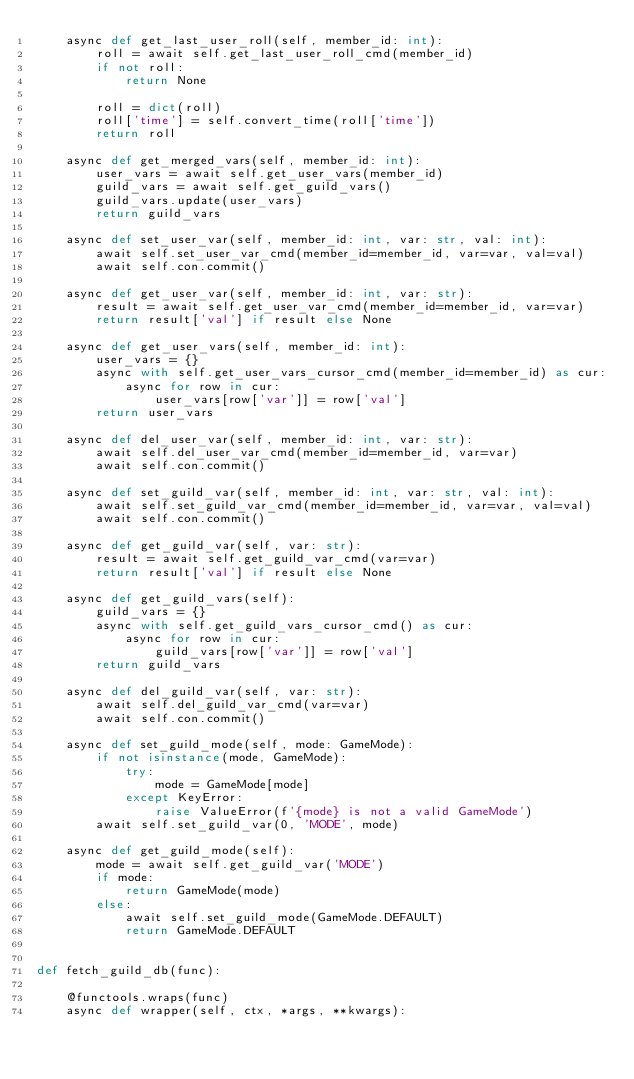<code> <loc_0><loc_0><loc_500><loc_500><_Python_>    async def get_last_user_roll(self, member_id: int):
        roll = await self.get_last_user_roll_cmd(member_id)
        if not roll:
            return None

        roll = dict(roll)
        roll['time'] = self.convert_time(roll['time'])
        return roll

    async def get_merged_vars(self, member_id: int):
        user_vars = await self.get_user_vars(member_id)
        guild_vars = await self.get_guild_vars()
        guild_vars.update(user_vars)
        return guild_vars

    async def set_user_var(self, member_id: int, var: str, val: int):
        await self.set_user_var_cmd(member_id=member_id, var=var, val=val)
        await self.con.commit()

    async def get_user_var(self, member_id: int, var: str):
        result = await self.get_user_var_cmd(member_id=member_id, var=var)
        return result['val'] if result else None
    
    async def get_user_vars(self, member_id: int):
        user_vars = {}
        async with self.get_user_vars_cursor_cmd(member_id=member_id) as cur:
            async for row in cur:
                user_vars[row['var']] = row['val']
        return user_vars

    async def del_user_var(self, member_id: int, var: str):
        await self.del_user_var_cmd(member_id=member_id, var=var)
        await self.con.commit()

    async def set_guild_var(self, member_id: int, var: str, val: int):
        await self.set_guild_var_cmd(member_id=member_id, var=var, val=val)
        await self.con.commit()

    async def get_guild_var(self, var: str):
        result = await self.get_guild_var_cmd(var=var)
        return result['val'] if result else None
    
    async def get_guild_vars(self):
        guild_vars = {}
        async with self.get_guild_vars_cursor_cmd() as cur:
            async for row in cur:
                guild_vars[row['var']] = row['val']
        return guild_vars

    async def del_guild_var(self, var: str):
        await self.del_guild_var_cmd(var=var)
        await self.con.commit()
    
    async def set_guild_mode(self, mode: GameMode):
        if not isinstance(mode, GameMode):
            try:
                mode = GameMode[mode]
            except KeyError:
                raise ValueError(f'{mode} is not a valid GameMode')
        await self.set_guild_var(0, 'MODE', mode)

    async def get_guild_mode(self):
        mode = await self.get_guild_var('MODE')
        if mode:
            return GameMode(mode)
        else:
            await self.set_guild_mode(GameMode.DEFAULT)
            return GameMode.DEFAULT


def fetch_guild_db(func):

    @functools.wraps(func)
    async def wrapper(self, ctx, *args, **kwargs):</code> 